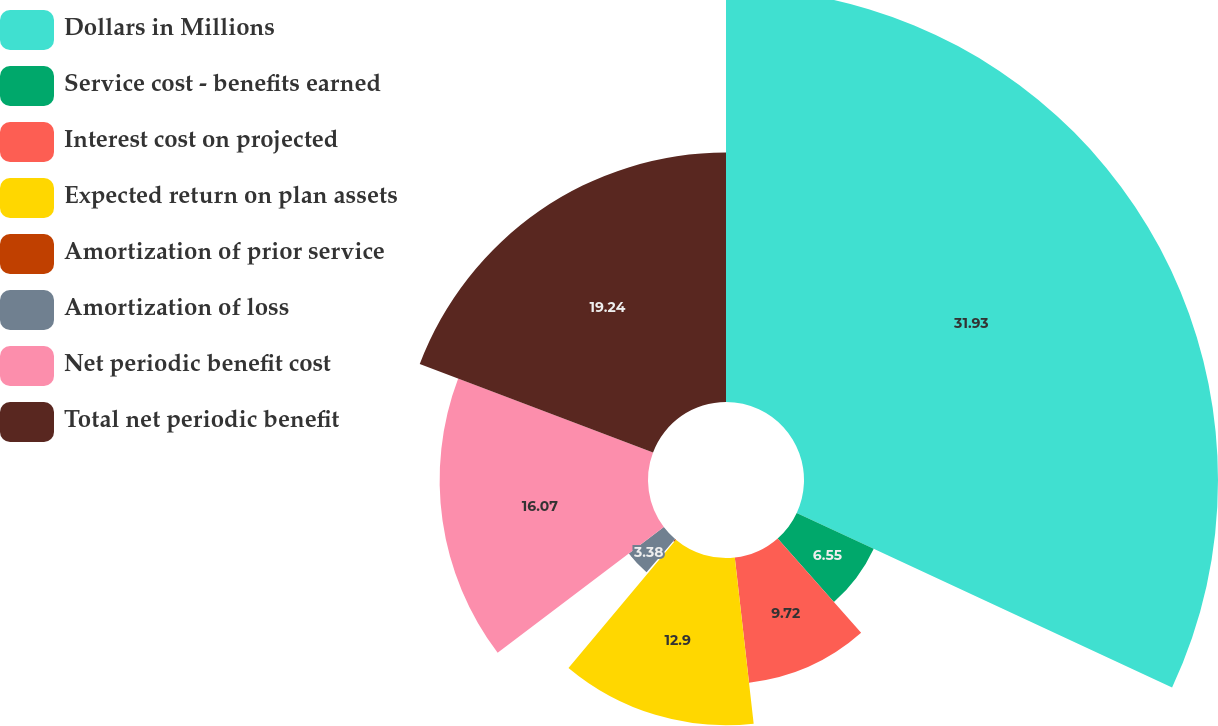Convert chart to OTSL. <chart><loc_0><loc_0><loc_500><loc_500><pie_chart><fcel>Dollars in Millions<fcel>Service cost - benefits earned<fcel>Interest cost on projected<fcel>Expected return on plan assets<fcel>Amortization of prior service<fcel>Amortization of loss<fcel>Net periodic benefit cost<fcel>Total net periodic benefit<nl><fcel>31.93%<fcel>6.55%<fcel>9.72%<fcel>12.9%<fcel>0.21%<fcel>3.38%<fcel>16.07%<fcel>19.24%<nl></chart> 